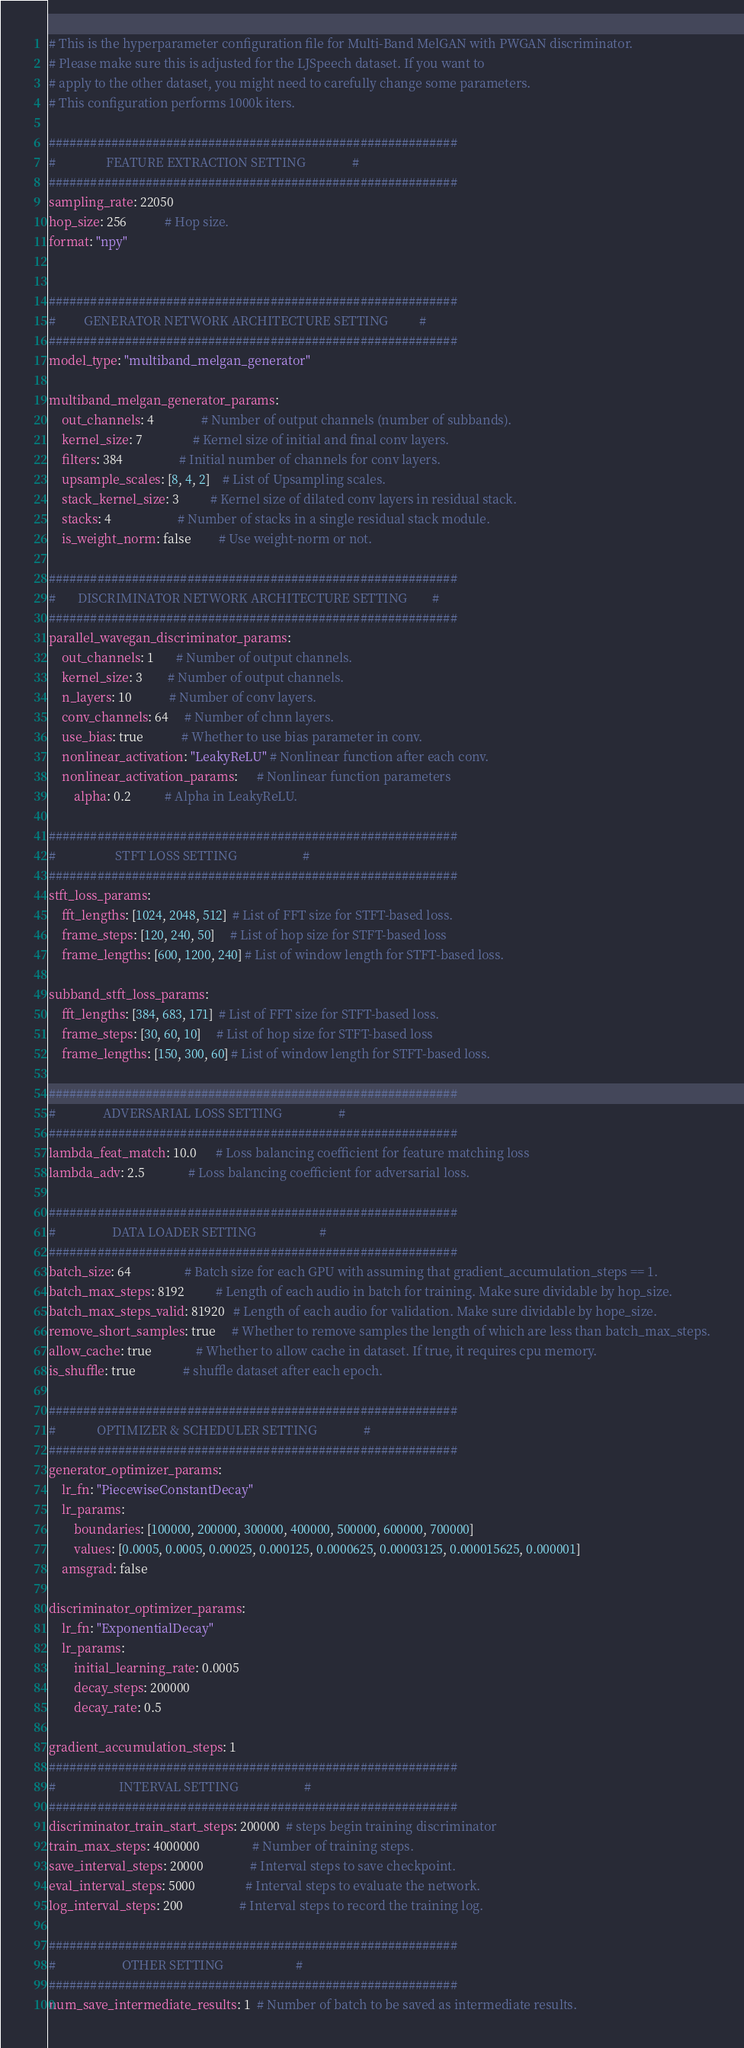Convert code to text. <code><loc_0><loc_0><loc_500><loc_500><_YAML_>
# This is the hyperparameter configuration file for Multi-Band MelGAN with PWGAN discriminator.
# Please make sure this is adjusted for the LJSpeech dataset. If you want to
# apply to the other dataset, you might need to carefully change some parameters.
# This configuration performs 1000k iters.

###########################################################
#                FEATURE EXTRACTION SETTING               #
###########################################################
sampling_rate: 22050
hop_size: 256            # Hop size.
format: "npy"


###########################################################
#         GENERATOR NETWORK ARCHITECTURE SETTING          #
###########################################################
model_type: "multiband_melgan_generator"

multiband_melgan_generator_params:
    out_channels: 4               # Number of output channels (number of subbands).
    kernel_size: 7                # Kernel size of initial and final conv layers.
    filters: 384                  # Initial number of channels for conv layers.
    upsample_scales: [8, 4, 2]    # List of Upsampling scales.
    stack_kernel_size: 3          # Kernel size of dilated conv layers in residual stack.
    stacks: 4                     # Number of stacks in a single residual stack module.
    is_weight_norm: false         # Use weight-norm or not.

###########################################################
#       DISCRIMINATOR NETWORK ARCHITECTURE SETTING        #
###########################################################
parallel_wavegan_discriminator_params:
    out_channels: 1       # Number of output channels.
    kernel_size: 3        # Number of output channels.
    n_layers: 10            # Number of conv layers.
    conv_channels: 64     # Number of chnn layers.
    use_bias: true            # Whether to use bias parameter in conv.
    nonlinear_activation: "LeakyReLU" # Nonlinear function after each conv.
    nonlinear_activation_params:      # Nonlinear function parameters
        alpha: 0.2           # Alpha in LeakyReLU.

###########################################################
#                   STFT LOSS SETTING                     #
###########################################################
stft_loss_params:
    fft_lengths: [1024, 2048, 512]  # List of FFT size for STFT-based loss.
    frame_steps: [120, 240, 50]     # List of hop size for STFT-based loss
    frame_lengths: [600, 1200, 240] # List of window length for STFT-based loss.

subband_stft_loss_params:
    fft_lengths: [384, 683, 171]  # List of FFT size for STFT-based loss.
    frame_steps: [30, 60, 10]     # List of hop size for STFT-based loss
    frame_lengths: [150, 300, 60] # List of window length for STFT-based loss.

###########################################################
#               ADVERSARIAL LOSS SETTING                  #
###########################################################
lambda_feat_match: 10.0      # Loss balancing coefficient for feature matching loss
lambda_adv: 2.5              # Loss balancing coefficient for adversarial loss.

###########################################################
#                  DATA LOADER SETTING                    #
###########################################################
batch_size: 64                 # Batch size for each GPU with assuming that gradient_accumulation_steps == 1.
batch_max_steps: 8192          # Length of each audio in batch for training. Make sure dividable by hop_size.
batch_max_steps_valid: 81920   # Length of each audio for validation. Make sure dividable by hope_size.
remove_short_samples: true     # Whether to remove samples the length of which are less than batch_max_steps.
allow_cache: true              # Whether to allow cache in dataset. If true, it requires cpu memory.
is_shuffle: true               # shuffle dataset after each epoch.

###########################################################
#             OPTIMIZER & SCHEDULER SETTING               #
###########################################################
generator_optimizer_params:
    lr_fn: "PiecewiseConstantDecay"
    lr_params: 
        boundaries: [100000, 200000, 300000, 400000, 500000, 600000, 700000]
        values: [0.0005, 0.0005, 0.00025, 0.000125, 0.0000625, 0.00003125, 0.000015625, 0.000001]
    amsgrad: false

discriminator_optimizer_params:
    lr_fn: "ExponentialDecay"
    lr_params: 
        initial_learning_rate: 0.0005
        decay_steps: 200000
        decay_rate: 0.5

gradient_accumulation_steps: 1
###########################################################
#                    INTERVAL SETTING                     #
###########################################################
discriminator_train_start_steps: 200000  # steps begin training discriminator
train_max_steps: 4000000                 # Number of training steps.
save_interval_steps: 20000               # Interval steps to save checkpoint.
eval_interval_steps: 5000                # Interval steps to evaluate the network.
log_interval_steps: 200                  # Interval steps to record the training log.

###########################################################
#                     OTHER SETTING                       #
###########################################################
num_save_intermediate_results: 1  # Number of batch to be saved as intermediate results.
</code> 